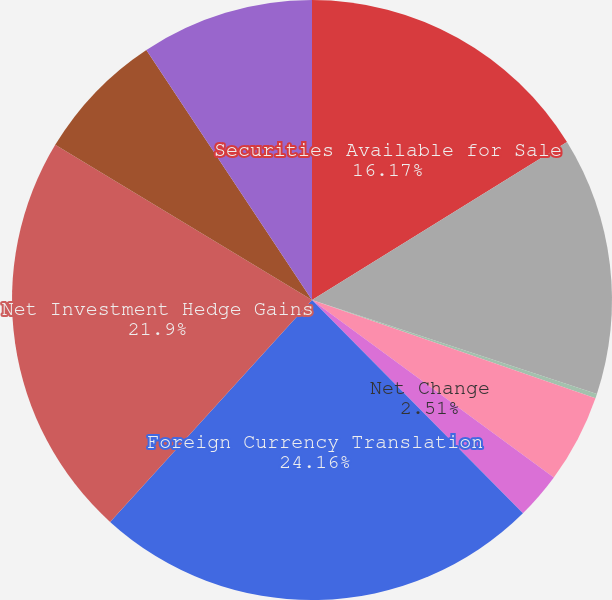<chart> <loc_0><loc_0><loc_500><loc_500><pie_chart><fcel>Securities Available for Sale<fcel>Net Change Unrealized (Losses)<fcel>Hedges Unrealized (Losses)<fcel>Flow Hedges Reclassification<fcel>Net Change<fcel>Foreign Currency Translation<fcel>Net Investment Hedge Gains<fcel>Net Actuarial Gains (Losses)<fcel>Reclassification Adjustment<nl><fcel>16.17%<fcel>13.9%<fcel>0.24%<fcel>4.77%<fcel>2.51%<fcel>24.16%<fcel>21.9%<fcel>7.04%<fcel>9.31%<nl></chart> 